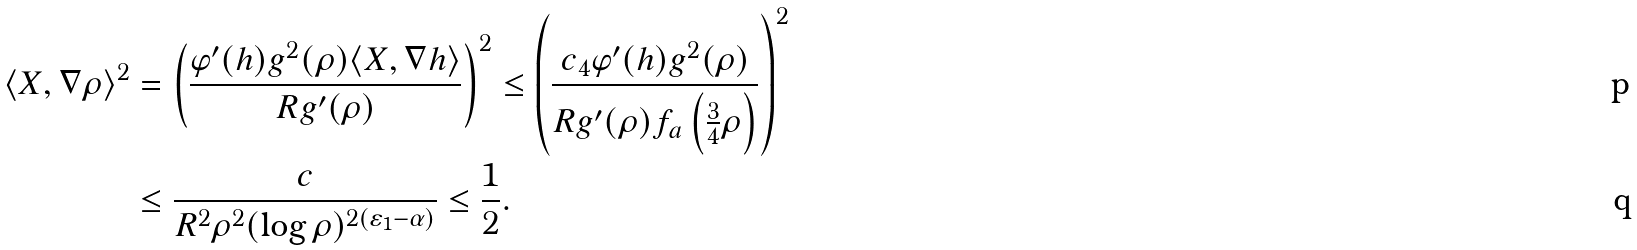Convert formula to latex. <formula><loc_0><loc_0><loc_500><loc_500>\langle X , \nabla \rho \rangle ^ { 2 } & = \left ( \frac { \varphi ^ { \prime } ( h ) g ^ { 2 } ( \rho ) \langle X , \nabla h \rangle } { R g ^ { \prime } ( \rho ) } \right ) ^ { 2 } \leq \left ( \frac { c _ { 4 } \varphi ^ { \prime } ( h ) g ^ { 2 } ( \rho ) } { R g ^ { \prime } ( \rho ) f _ { a } \left ( \frac { 3 } { 4 } \rho \right ) } \right ) ^ { 2 } \\ & \leq \frac { c } { R ^ { 2 } \rho ^ { 2 } ( \log \rho ) ^ { 2 ( \varepsilon _ { 1 } - \alpha ) } } \leq \frac { 1 } { 2 } .</formula> 